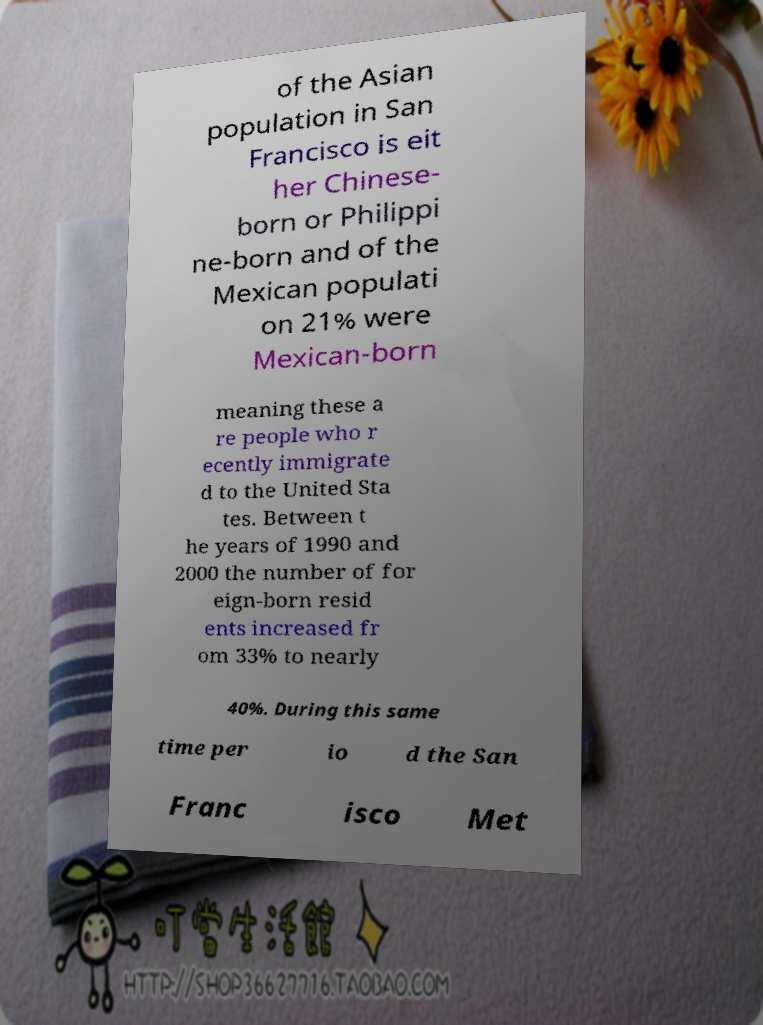Please read and relay the text visible in this image. What does it say? of the Asian population in San Francisco is eit her Chinese- born or Philippi ne-born and of the Mexican populati on 21% were Mexican-born meaning these a re people who r ecently immigrate d to the United Sta tes. Between t he years of 1990 and 2000 the number of for eign-born resid ents increased fr om 33% to nearly 40%. During this same time per io d the San Franc isco Met 